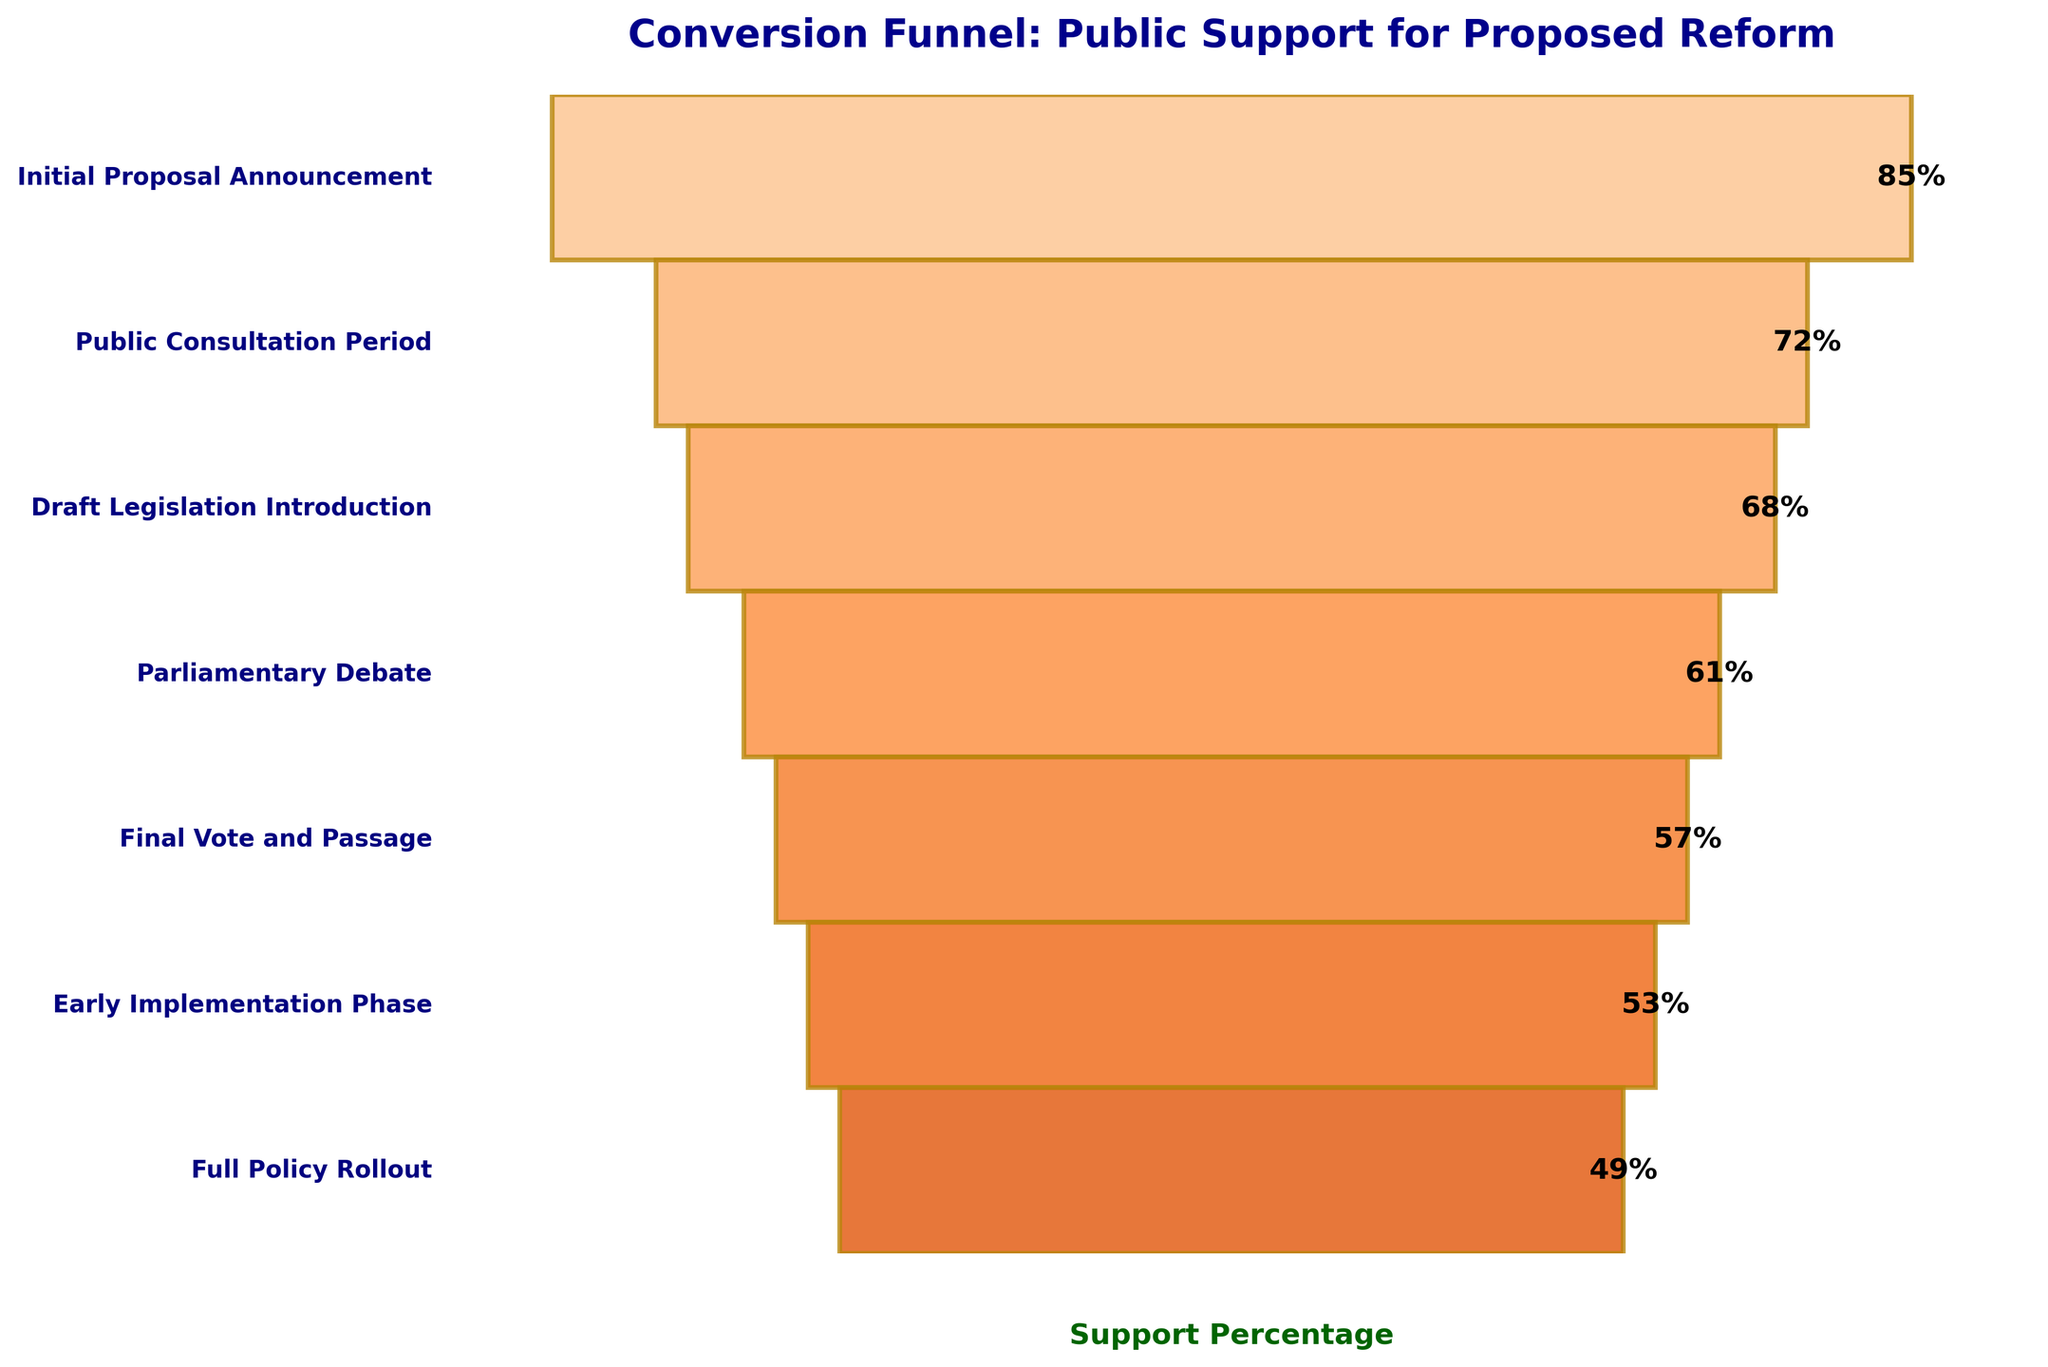What's the title of the chart? The title is found at the top of the chart in a larger and bolder font compared to other text elements.
Answer: Conversion Funnel: Public Support for Proposed Reform What stage has the lowest percentage of public support? Locate the stage at the bottom of the funnel and identify the corresponding percentage.
Answer: Full Policy Rollout What is the difference in support percentage between the Initial Proposal Announcement and the Public Consultation Period? Subtract the support percentage at the Public Consultation Period from the support percentage at the Initial Proposal Announcement: 85% - 72%.
Answer: 13% At which stage does the public support drop below 60% for the first time? Examine the percentages from top to bottom and identify the first stage where the percentage falls below 60%.
Answer: Parliamentary Debate What is the average support percentage across all stages? Sum all the support percentages and divide by the number of stages: (85 + 72 + 68 + 61 + 57 + 53 + 49) / 7. Detailed calculation steps: 445 / 7 = 63.57
Answer: 63.57% In which stage is the decrease in public support the largest compared to the previous stage? Calculate the differences in support percentages between consecutive stages and identify the largest difference: 
Public Consultation Period to Initial Proposal Announcement: 85 - 72 = 13; 
Draft Legislation Introduction to Public Consultation Period: 72 - 68 = 4; 
Parliamentary Debate to Draft Legislation Introduction: 68 - 61 = 7; 
Final Vote and Passage to Parliamentary Debate: 61 - 57 = 4; 
Early Implementation Phase to Final Vote and Passage: 57 - 53 = 4; 
Full Policy Rollout to Early Implementation Phase: 53 - 49 = 4; 
The largest difference is 13.
Answer: Public Consultation Period How many stages have a support percentage of 60% or higher? Count the number of stages where the support percentage is equal to or greater than 60%.
Answer: 4 By how much did public support decrease overall from the Initial Proposal Announcement to the Full Policy Rollout? Subtract the support percentage at the Full Policy Rollout from the Initial Proposal Announcement: 85 - 49.
Answer: 36% Which stage shows a support percentage of 68%? Identify the stage corresponding to the 68% support percentage in the funnel chart.
Answer: Draft Legislation Introduction If you were to rank the stages by public support, which stage would be the third highest? List the stages by their support percentages in descending order and identify the third stage: 85% (Initial Proposal Announcement), 72% (Public Consultation Period), 68% (Draft Legislation Introduction), so the third would be Draft Legislation Introduction.
Answer: Draft Legislation Introduction 